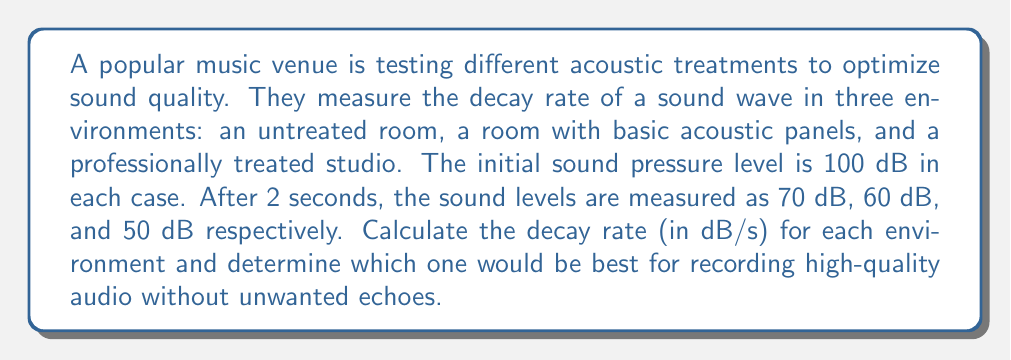Give your solution to this math problem. To solve this problem, we need to calculate the decay rate for each environment. The decay rate is the rate at which the sound pressure level decreases over time.

The formula for decay rate is:

$$\text{Decay Rate} = \frac{\text{Initial SPL} - \text{Final SPL}}{\text{Time}}$$

Where SPL is Sound Pressure Level in decibels (dB), and time is in seconds.

For each environment:

1. Untreated room:
   $$\text{Decay Rate}_1 = \frac{100 \text{ dB} - 70 \text{ dB}}{2 \text{ s}} = 15 \text{ dB/s}$$

2. Room with basic acoustic panels:
   $$\text{Decay Rate}_2 = \frac{100 \text{ dB} - 60 \text{ dB}}{2 \text{ s}} = 20 \text{ dB/s}$$

3. Professionally treated studio:
   $$\text{Decay Rate}_3 = \frac{100 \text{ dB} - 50 \text{ dB}}{2 \text{ s}} = 25 \text{ dB/s}$$

For high-quality audio recording without unwanted echoes, we generally want a faster decay rate. This helps to reduce reverberation and improve clarity. Therefore, the environment with the highest decay rate would be the best choice.

Comparing the decay rates:
$25 \text{ dB/s} > 20 \text{ dB/s} > 15 \text{ dB/s}$

The professionally treated studio has the highest decay rate, making it the best choice for recording high-quality audio without unwanted echoes.
Answer: The decay rates are:
1. Untreated room: 15 dB/s
2. Room with basic acoustic panels: 20 dB/s
3. Professionally treated studio: 25 dB/s

The professionally treated studio, with the highest decay rate of 25 dB/s, would be the best for recording high-quality audio without unwanted echoes. 